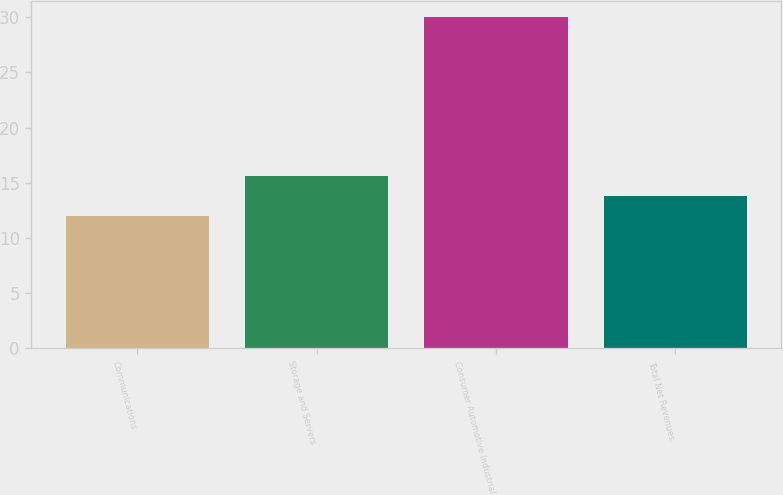Convert chart to OTSL. <chart><loc_0><loc_0><loc_500><loc_500><bar_chart><fcel>Communications<fcel>Storage and Servers<fcel>Consumer Automotive Industrial<fcel>Total Net Revenues<nl><fcel>12<fcel>15.6<fcel>30<fcel>13.8<nl></chart> 